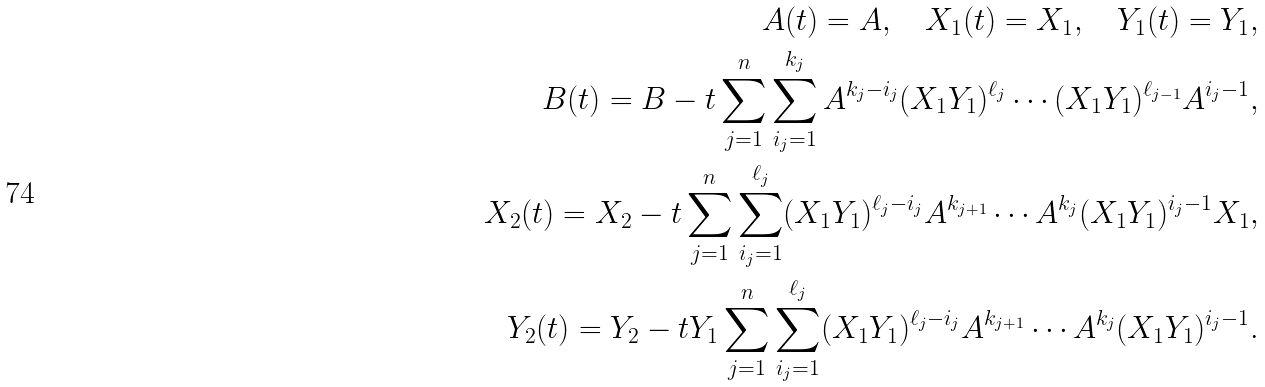Convert formula to latex. <formula><loc_0><loc_0><loc_500><loc_500>A ( t ) = A , \quad X _ { 1 } ( t ) = X _ { 1 } , \quad Y _ { 1 } ( t ) = Y _ { 1 } , \\ B ( t ) = B - t \sum _ { j = 1 } ^ { n } \sum _ { i _ { j } = 1 } ^ { k _ { j } } A ^ { k _ { j } - i _ { j } } ( X _ { 1 } Y _ { 1 } ) ^ { \ell _ { j } } \cdots ( X _ { 1 } Y _ { 1 } ) ^ { \ell _ { j - 1 } } A ^ { i _ { j } - 1 } , \\ X _ { 2 } ( t ) = X _ { 2 } - t \sum _ { j = 1 } ^ { n } \sum _ { i _ { j } = 1 } ^ { \ell _ { j } } ( X _ { 1 } Y _ { 1 } ) ^ { \ell _ { j } - i _ { j } } A ^ { k _ { j + 1 } } \cdots A ^ { k _ { j } } ( X _ { 1 } Y _ { 1 } ) ^ { i _ { j } - 1 } X _ { 1 } , \\ Y _ { 2 } ( t ) = Y _ { 2 } - t Y _ { 1 } \sum _ { j = 1 } ^ { n } \sum _ { i _ { j } = 1 } ^ { \ell _ { j } } ( X _ { 1 } Y _ { 1 } ) ^ { \ell _ { j } - i _ { j } } A ^ { k _ { j + 1 } } \cdots A ^ { k _ { j } } ( X _ { 1 } Y _ { 1 } ) ^ { i _ { j } - 1 } .</formula> 